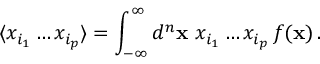<formula> <loc_0><loc_0><loc_500><loc_500>\langle x _ { i _ { 1 } } \dots x _ { i _ { p } } \rangle = \int _ { - \infty } ^ { \infty } d ^ { n } { x } \ x _ { i _ { 1 } } \dots x _ { i _ { p } } \, f ( { x } ) \, .</formula> 